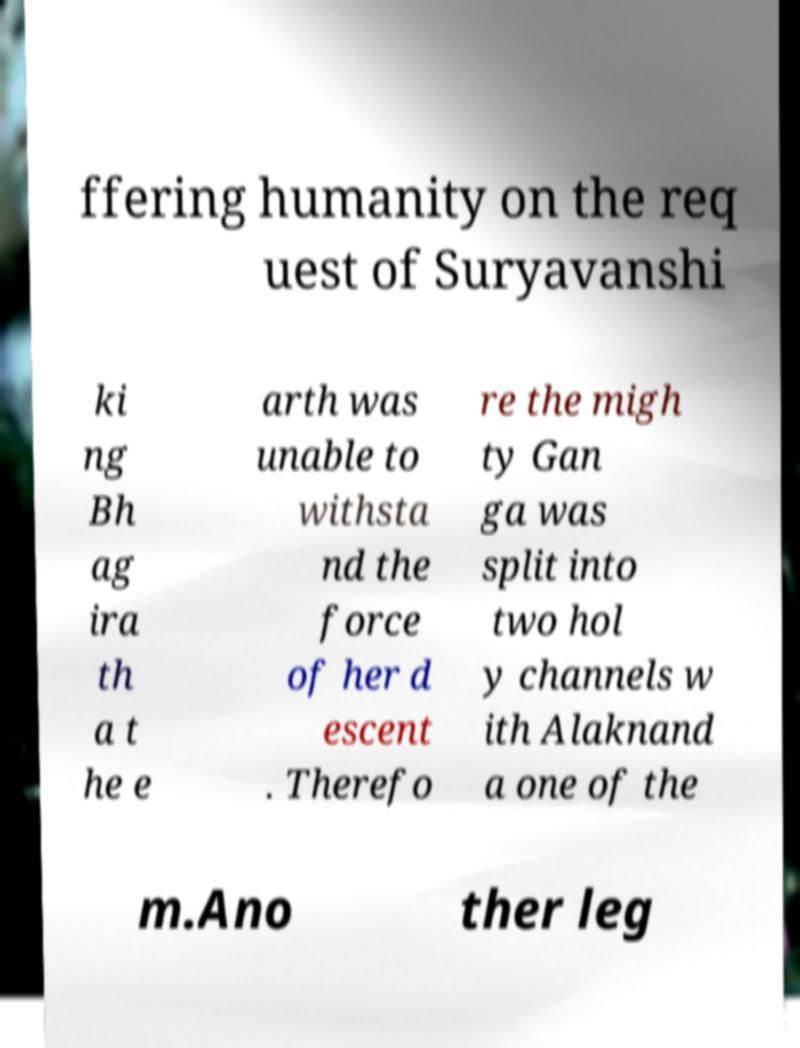Can you accurately transcribe the text from the provided image for me? ffering humanity on the req uest of Suryavanshi ki ng Bh ag ira th a t he e arth was unable to withsta nd the force of her d escent . Therefo re the migh ty Gan ga was split into two hol y channels w ith Alaknand a one of the m.Ano ther leg 